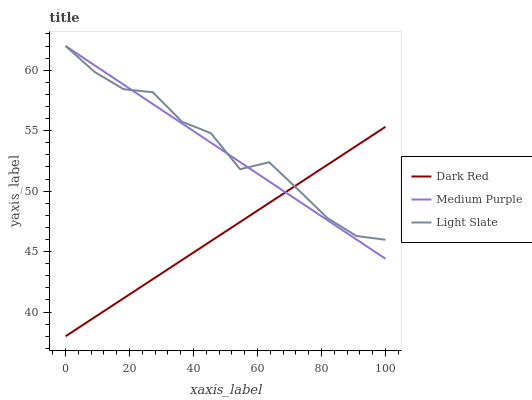Does Dark Red have the minimum area under the curve?
Answer yes or no. Yes. Does Light Slate have the maximum area under the curve?
Answer yes or no. Yes. Does Light Slate have the minimum area under the curve?
Answer yes or no. No. Does Dark Red have the maximum area under the curve?
Answer yes or no. No. Is Dark Red the smoothest?
Answer yes or no. Yes. Is Light Slate the roughest?
Answer yes or no. Yes. Is Light Slate the smoothest?
Answer yes or no. No. Is Dark Red the roughest?
Answer yes or no. No. Does Dark Red have the lowest value?
Answer yes or no. Yes. Does Light Slate have the lowest value?
Answer yes or no. No. Does Light Slate have the highest value?
Answer yes or no. Yes. Does Dark Red have the highest value?
Answer yes or no. No. Does Medium Purple intersect Light Slate?
Answer yes or no. Yes. Is Medium Purple less than Light Slate?
Answer yes or no. No. Is Medium Purple greater than Light Slate?
Answer yes or no. No. 